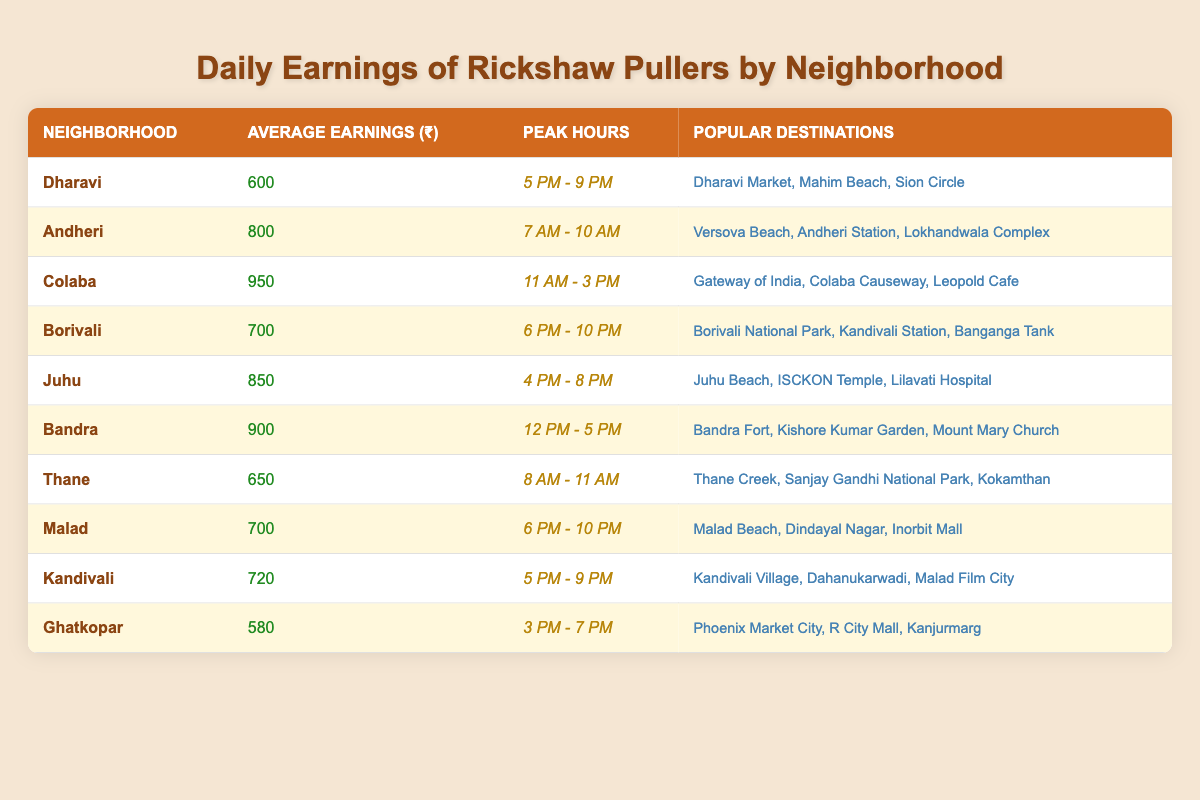What is the average earnings of rickshaw pullers in Colaba? The table shows that the average earnings in Colaba is ₹950.
Answer: ₹950 Which neighborhood has the highest average earnings? By comparing all neighborhoods, Colaba has the highest average earnings at ₹950.
Answer: Colaba What are the peak hours for earnings in Dharavi? From the table, the peak hours for Dharavi are from 5 PM to 9 PM.
Answer: 5 PM - 9 PM How much more do rickshaw pullers earn on average in Bandra compared to Thane? Bandra averages ₹900 and Thane averages ₹650. The difference is ₹900 - ₹650 = ₹250.
Answer: ₹250 Which neighborhood has the least average earnings, and what is that amount? Ghatkopar has the least average earnings at ₹580.
Answer: Ghatkopar, ₹580 During which hours do rickshaw pullers earn the most in Juhu? The table specifies the peak hours in Juhu as 4 PM to 8 PM.
Answer: 4 PM - 8 PM If you combine the average earnings of Malad and Kandivali, what is the total? Malad averages ₹700 and Kandivali averages ₹720. Adding them gives ₹700 + ₹720 = ₹1420.
Answer: ₹1420 Is the average earnings in Andheri greater than that in Borivali? Andheri has average earnings of ₹800 while Borivali has ₹700, so yes, Andheri's earnings are greater.
Answer: Yes What popular destinations are mentioned for Borivali? The table lists Borivali National Park, Kandivali Station, and Banganga Tank as popular destinations in Borivali.
Answer: Borivali National Park, Kandivali Station, Banganga Tank What is the median average earnings of the rickshaw pullers listed? To find the median, we first list the averages in order: 580, 600, 650, 700, 700, 720, 800, 850, 900, 950. There are 10 values, so the median is the average of the 5th and 6th values: (700 + 720)/2 = 710.
Answer: ₹710 